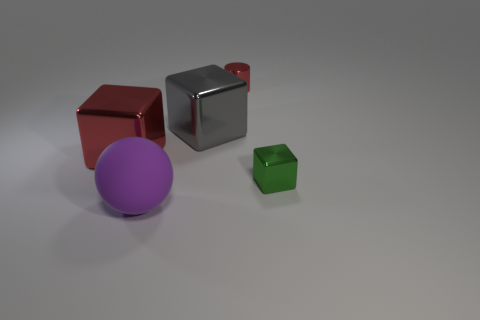How many green objects are either tiny shiny cylinders or blocks?
Provide a short and direct response. 1. The gray metallic object has what shape?
Keep it short and to the point. Cube. How many other things are there of the same shape as the big gray thing?
Give a very brief answer. 2. There is a shiny cube on the left side of the purple ball; what color is it?
Keep it short and to the point. Red. Are the ball and the large red thing made of the same material?
Make the answer very short. No. What number of objects are tiny blue matte cylinders or red metal objects on the left side of the shiny cylinder?
Give a very brief answer. 1. The block that is the same color as the small shiny cylinder is what size?
Your response must be concise. Large. There is a red thing to the right of the purple matte object; what is its shape?
Your answer should be compact. Cylinder. There is a cube on the right side of the tiny cylinder; is its color the same as the matte thing?
Provide a short and direct response. No. What material is the large thing that is the same color as the small cylinder?
Provide a succinct answer. Metal. 